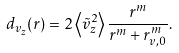Convert formula to latex. <formula><loc_0><loc_0><loc_500><loc_500>d _ { v _ { z } } ( r ) = 2 \left \langle \tilde { v } _ { z } ^ { 2 } \right \rangle \frac { r ^ { m } } { r ^ { m } + r _ { v , 0 } ^ { m } } .</formula> 